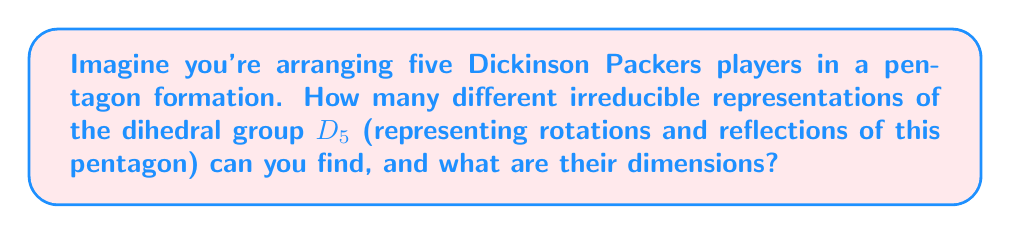What is the answer to this math problem? Let's break this down step-by-step:

1) The dihedral group $D_5$ has order 10, consisting of 5 rotations and 5 reflections.

2) For any group, the sum of the squares of the dimensions of its irreducible representations equals the order of the group. So we need to find dimensions that satisfy:

   $$a^2 + b^2 + c^2 + ... = 10$$

3) We know that $D_5$ always has two 1-dimensional representations:
   - The trivial representation
   - The sign representation (determinant)

4) The remaining irreducible representations must have dimensions that sum to 8 (because $1^2 + 1^2 + 8 = 10$).

5) The only way to decompose 8 into a sum of squares is $2^2 + 2^2$, which gives us two 2-dimensional representations.

6) To confirm, let's count the conjugacy classes of $D_5$:
   - The identity element
   - 2 classes of rotations (rotations by 72° and 144°)
   - 2 classes of reflections (through vertices and through edges)

   This gives us 5 conjugacy classes, which matches our count of irreducible representations (2 of dimension 1 and 2 of dimension 2).

Therefore, we have found all irreducible representations of $D_5$.
Answer: 4 irreducible representations: two 1-dimensional and two 2-dimensional 